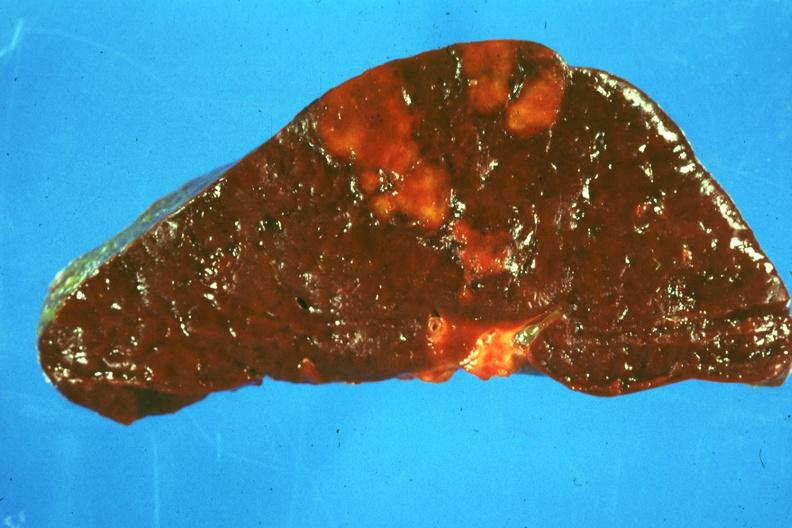s hematologic present?
Answer the question using a single word or phrase. Yes 